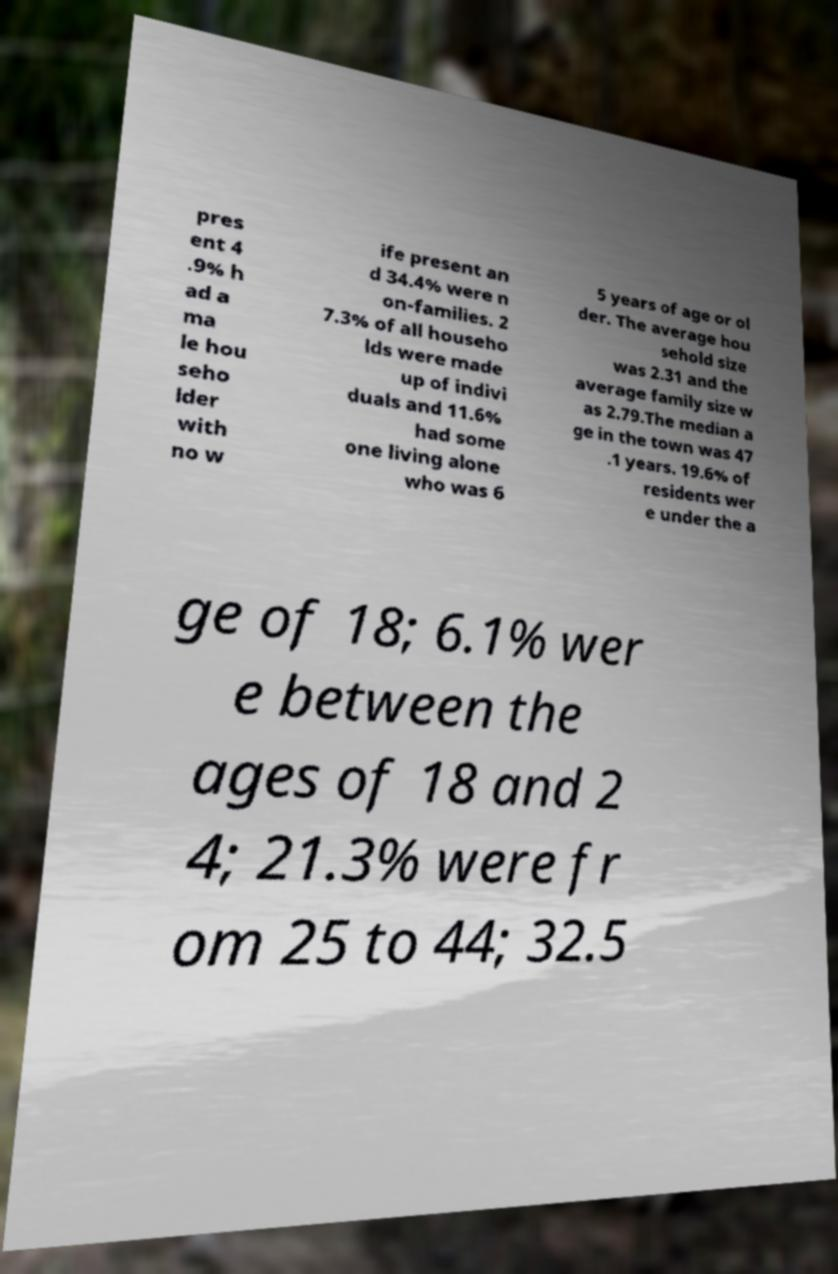Could you extract and type out the text from this image? pres ent 4 .9% h ad a ma le hou seho lder with no w ife present an d 34.4% were n on-families. 2 7.3% of all househo lds were made up of indivi duals and 11.6% had some one living alone who was 6 5 years of age or ol der. The average hou sehold size was 2.31 and the average family size w as 2.79.The median a ge in the town was 47 .1 years. 19.6% of residents wer e under the a ge of 18; 6.1% wer e between the ages of 18 and 2 4; 21.3% were fr om 25 to 44; 32.5 